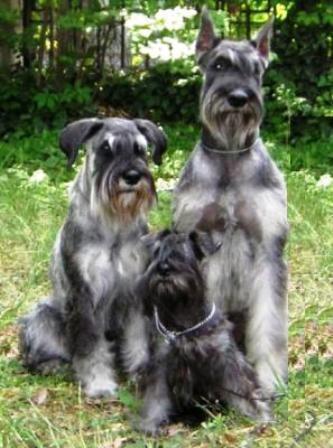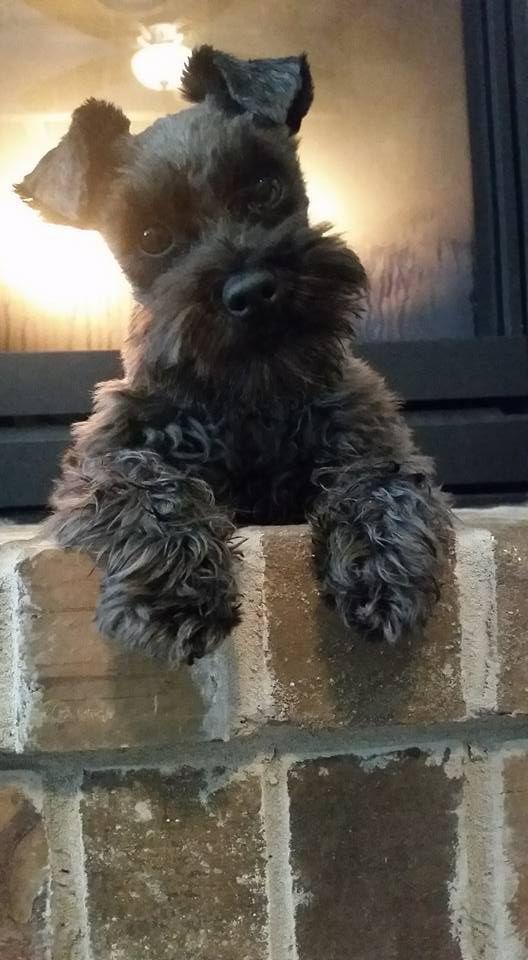The first image is the image on the left, the second image is the image on the right. Evaluate the accuracy of this statement regarding the images: "One dog's teeth are visible.". Is it true? Answer yes or no. No. The first image is the image on the left, the second image is the image on the right. For the images shown, is this caption "One image shows a dog standing upright with at least one paw propped on something flat, and the other image includes at least two schnauzers." true? Answer yes or no. Yes. 